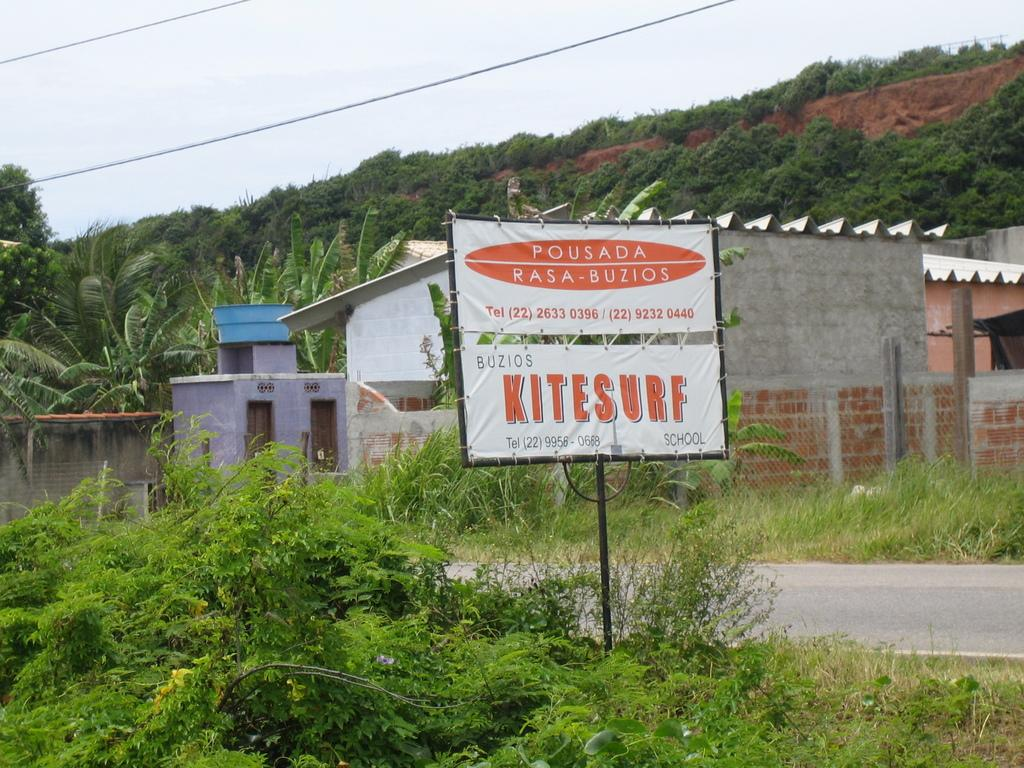What is the main feature of the image? There is a road in the image. What else can be seen in the image besides the road? There is a white color board, buildings, grass, trees, sky, and wires visible in the image. What is the purpose of the white color board? Something is written on the white color board, which suggests it might be used for communication or displaying information. What type of natural environment is present in the image? The image features grass and trees, which are part of the natural environment. What is the condition of the heart in the image? There is no heart present in the image. How many adjustments are needed to make the wires straight in the image? The wires in the image are already straight, so no adjustments are needed. 